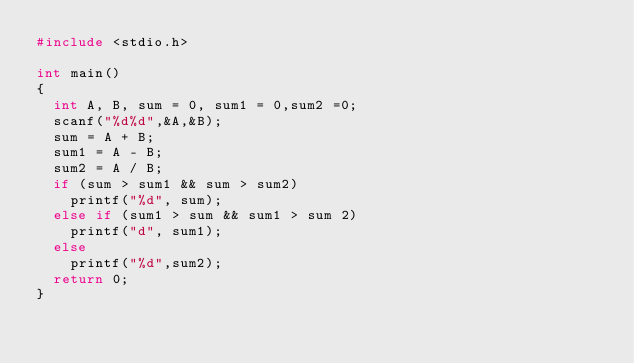Convert code to text. <code><loc_0><loc_0><loc_500><loc_500><_C_>#include <stdio.h>

int main()
{
	int A, B, sum = 0, sum1 = 0,sum2 =0;
	scanf("%d%d",&A,&B);
	sum = A + B;
	sum1 = A - B;
	sum2 = A / B;
	if (sum > sum1 && sum > sum2)
		printf("%d", sum);
	else if (sum1 > sum && sum1 > sum 2)
		printf("d", sum1);
	else
		printf("%d",sum2);
	return 0;
}</code> 